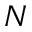Convert formula to latex. <formula><loc_0><loc_0><loc_500><loc_500>N</formula> 